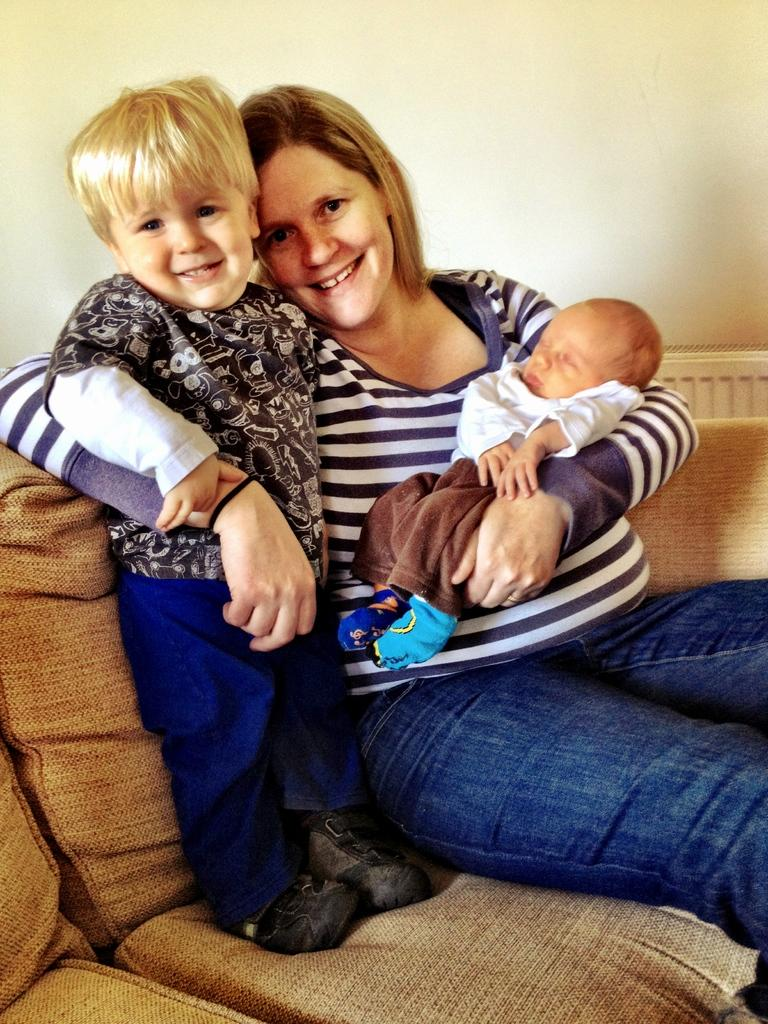What is the woman in the image doing? The woman is sitting and holding a baby in the image. Can you describe the position of the kid in the image? The kid is standing on a sofa in the image. What can be seen in the background of the image? There is a wall visible in the image. What type of song is the crook singing in the image? There is no crook or song present in the image. What is the tendency of the baby in the image? The baby's tendency cannot be determined from the image, as it is being held by the woman. 